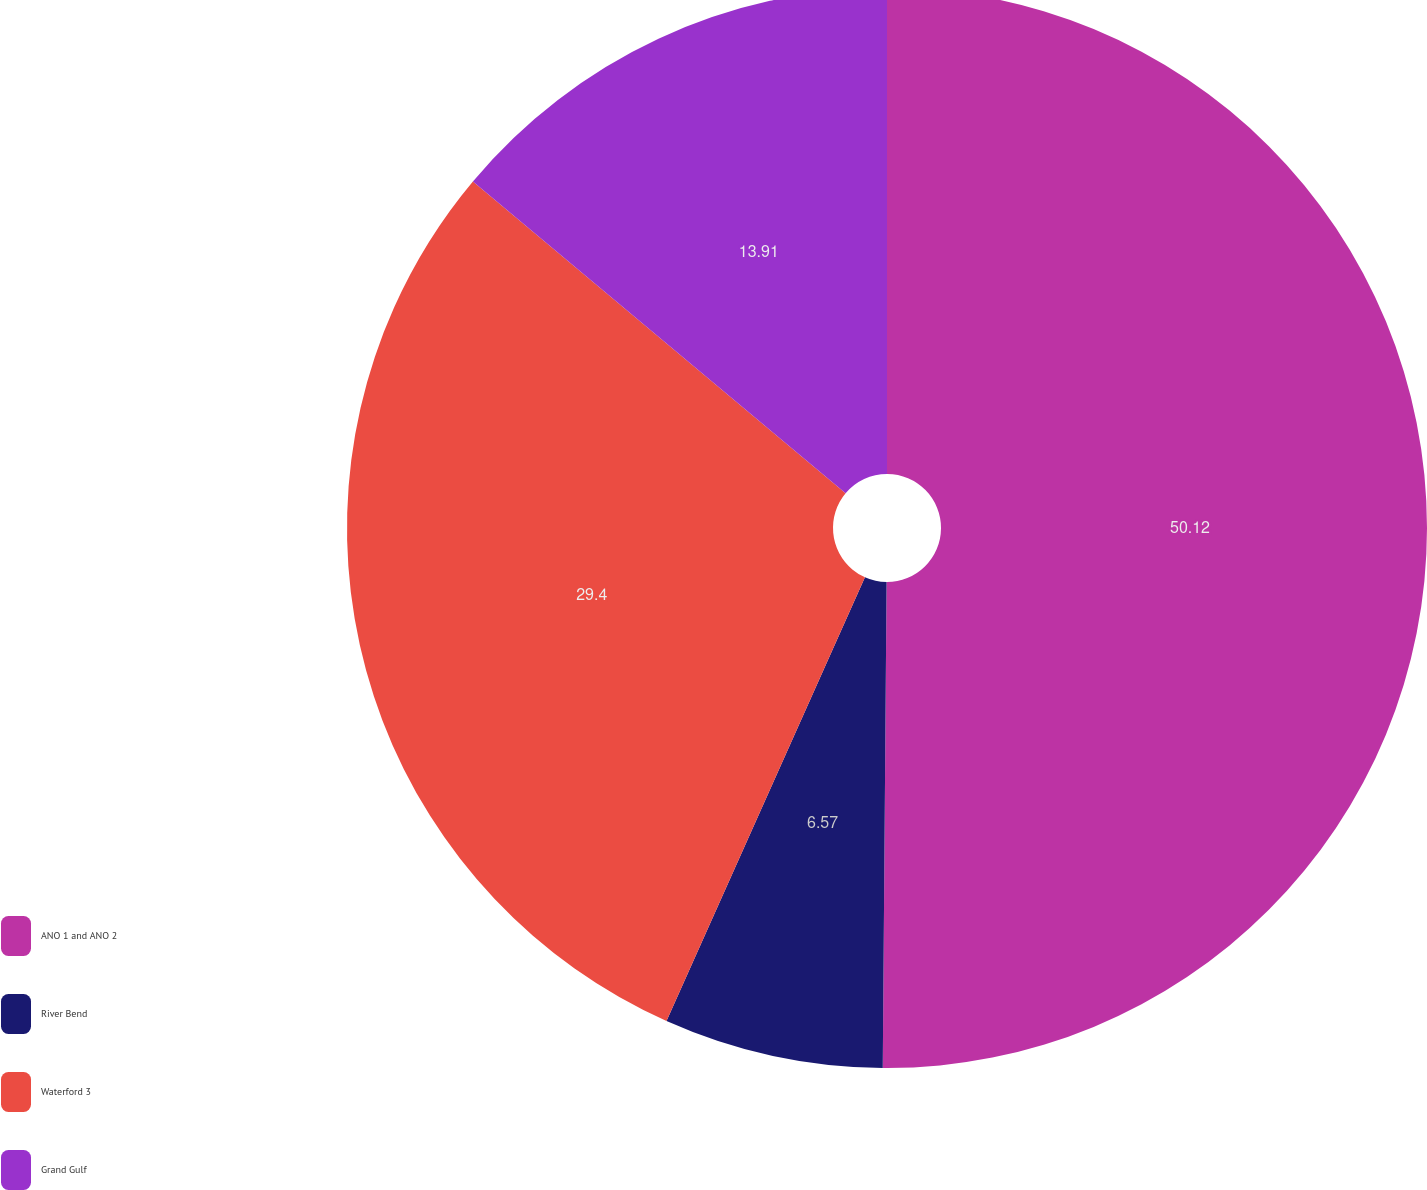Convert chart. <chart><loc_0><loc_0><loc_500><loc_500><pie_chart><fcel>ANO 1 and ANO 2<fcel>River Bend<fcel>Waterford 3<fcel>Grand Gulf<nl><fcel>50.13%<fcel>6.57%<fcel>29.4%<fcel>13.91%<nl></chart> 